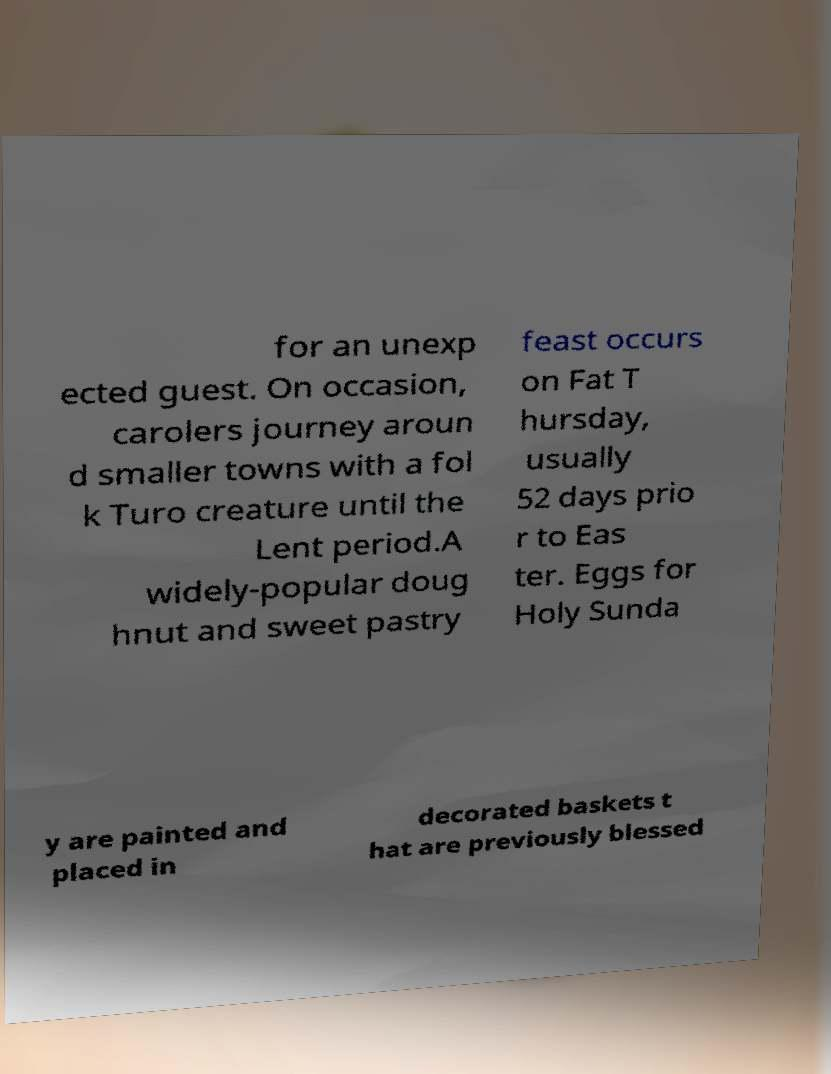Please read and relay the text visible in this image. What does it say? for an unexp ected guest. On occasion, carolers journey aroun d smaller towns with a fol k Turo creature until the Lent period.A widely-popular doug hnut and sweet pastry feast occurs on Fat T hursday, usually 52 days prio r to Eas ter. Eggs for Holy Sunda y are painted and placed in decorated baskets t hat are previously blessed 